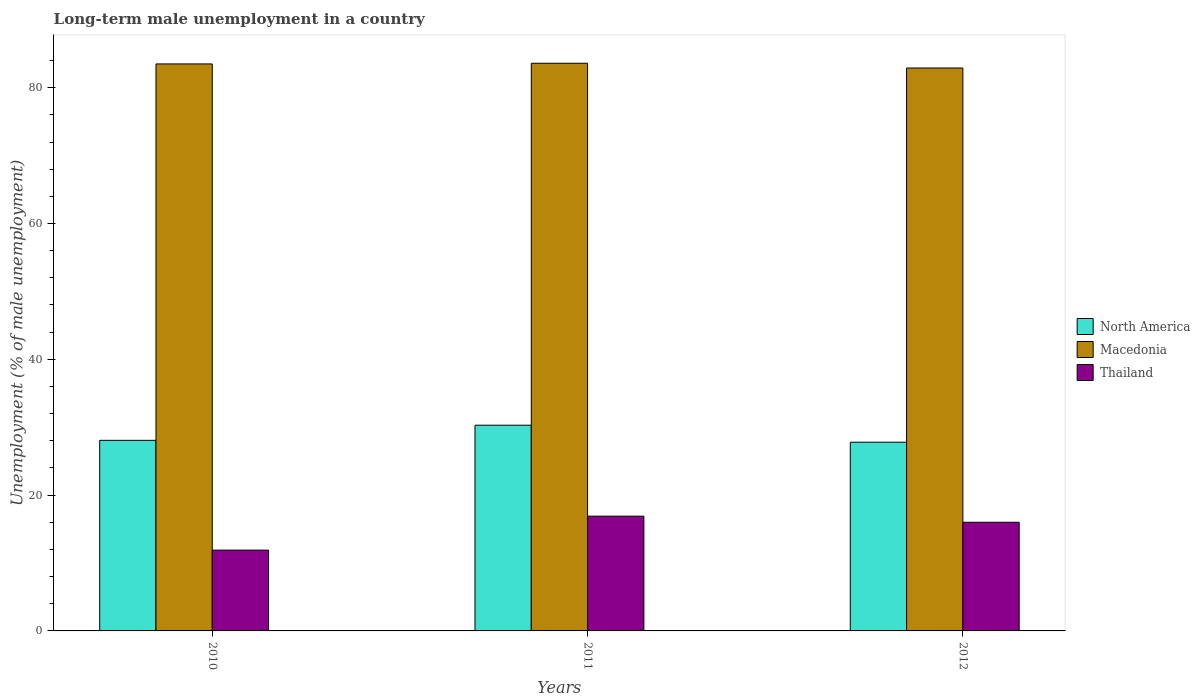How many groups of bars are there?
Offer a very short reply. 3. Are the number of bars per tick equal to the number of legend labels?
Provide a short and direct response. Yes. Are the number of bars on each tick of the X-axis equal?
Provide a short and direct response. Yes. How many bars are there on the 2nd tick from the left?
Keep it short and to the point. 3. What is the percentage of long-term unemployed male population in Macedonia in 2010?
Provide a short and direct response. 83.5. Across all years, what is the maximum percentage of long-term unemployed male population in Macedonia?
Provide a short and direct response. 83.6. Across all years, what is the minimum percentage of long-term unemployed male population in North America?
Keep it short and to the point. 27.79. What is the total percentage of long-term unemployed male population in Macedonia in the graph?
Provide a succinct answer. 250. What is the difference between the percentage of long-term unemployed male population in Macedonia in 2010 and that in 2012?
Your response must be concise. 0.6. What is the difference between the percentage of long-term unemployed male population in North America in 2010 and the percentage of long-term unemployed male population in Macedonia in 2012?
Provide a short and direct response. -54.83. What is the average percentage of long-term unemployed male population in North America per year?
Offer a very short reply. 28.72. In the year 2012, what is the difference between the percentage of long-term unemployed male population in Thailand and percentage of long-term unemployed male population in Macedonia?
Provide a short and direct response. -66.9. In how many years, is the percentage of long-term unemployed male population in Thailand greater than 4 %?
Your answer should be compact. 3. What is the ratio of the percentage of long-term unemployed male population in Thailand in 2010 to that in 2012?
Your answer should be compact. 0.74. What is the difference between the highest and the second highest percentage of long-term unemployed male population in Macedonia?
Offer a terse response. 0.1. What is the difference between the highest and the lowest percentage of long-term unemployed male population in North America?
Give a very brief answer. 2.51. In how many years, is the percentage of long-term unemployed male population in North America greater than the average percentage of long-term unemployed male population in North America taken over all years?
Offer a terse response. 1. Is the sum of the percentage of long-term unemployed male population in North America in 2010 and 2011 greater than the maximum percentage of long-term unemployed male population in Thailand across all years?
Offer a terse response. Yes. What does the 3rd bar from the left in 2012 represents?
Make the answer very short. Thailand. What does the 3rd bar from the right in 2011 represents?
Your answer should be compact. North America. Is it the case that in every year, the sum of the percentage of long-term unemployed male population in North America and percentage of long-term unemployed male population in Thailand is greater than the percentage of long-term unemployed male population in Macedonia?
Give a very brief answer. No. How many bars are there?
Give a very brief answer. 9. What is the difference between two consecutive major ticks on the Y-axis?
Provide a succinct answer. 20. Does the graph contain grids?
Offer a terse response. No. Where does the legend appear in the graph?
Your response must be concise. Center right. How many legend labels are there?
Offer a terse response. 3. What is the title of the graph?
Ensure brevity in your answer.  Long-term male unemployment in a country. What is the label or title of the Y-axis?
Ensure brevity in your answer.  Unemployment (% of male unemployment). What is the Unemployment (% of male unemployment) of North America in 2010?
Provide a short and direct response. 28.07. What is the Unemployment (% of male unemployment) of Macedonia in 2010?
Give a very brief answer. 83.5. What is the Unemployment (% of male unemployment) of Thailand in 2010?
Offer a very short reply. 11.9. What is the Unemployment (% of male unemployment) of North America in 2011?
Offer a terse response. 30.3. What is the Unemployment (% of male unemployment) of Macedonia in 2011?
Give a very brief answer. 83.6. What is the Unemployment (% of male unemployment) in Thailand in 2011?
Make the answer very short. 16.9. What is the Unemployment (% of male unemployment) in North America in 2012?
Keep it short and to the point. 27.79. What is the Unemployment (% of male unemployment) of Macedonia in 2012?
Offer a terse response. 82.9. What is the Unemployment (% of male unemployment) in Thailand in 2012?
Your response must be concise. 16. Across all years, what is the maximum Unemployment (% of male unemployment) in North America?
Offer a terse response. 30.3. Across all years, what is the maximum Unemployment (% of male unemployment) of Macedonia?
Give a very brief answer. 83.6. Across all years, what is the maximum Unemployment (% of male unemployment) in Thailand?
Provide a succinct answer. 16.9. Across all years, what is the minimum Unemployment (% of male unemployment) of North America?
Your answer should be very brief. 27.79. Across all years, what is the minimum Unemployment (% of male unemployment) of Macedonia?
Make the answer very short. 82.9. Across all years, what is the minimum Unemployment (% of male unemployment) in Thailand?
Ensure brevity in your answer.  11.9. What is the total Unemployment (% of male unemployment) of North America in the graph?
Keep it short and to the point. 86.16. What is the total Unemployment (% of male unemployment) in Macedonia in the graph?
Make the answer very short. 250. What is the total Unemployment (% of male unemployment) of Thailand in the graph?
Make the answer very short. 44.8. What is the difference between the Unemployment (% of male unemployment) of North America in 2010 and that in 2011?
Your answer should be very brief. -2.23. What is the difference between the Unemployment (% of male unemployment) in Macedonia in 2010 and that in 2011?
Provide a short and direct response. -0.1. What is the difference between the Unemployment (% of male unemployment) of North America in 2010 and that in 2012?
Offer a very short reply. 0.28. What is the difference between the Unemployment (% of male unemployment) in Macedonia in 2010 and that in 2012?
Your answer should be very brief. 0.6. What is the difference between the Unemployment (% of male unemployment) of North America in 2011 and that in 2012?
Your answer should be very brief. 2.51. What is the difference between the Unemployment (% of male unemployment) of Macedonia in 2011 and that in 2012?
Keep it short and to the point. 0.7. What is the difference between the Unemployment (% of male unemployment) of North America in 2010 and the Unemployment (% of male unemployment) of Macedonia in 2011?
Ensure brevity in your answer.  -55.53. What is the difference between the Unemployment (% of male unemployment) in North America in 2010 and the Unemployment (% of male unemployment) in Thailand in 2011?
Your response must be concise. 11.17. What is the difference between the Unemployment (% of male unemployment) in Macedonia in 2010 and the Unemployment (% of male unemployment) in Thailand in 2011?
Offer a terse response. 66.6. What is the difference between the Unemployment (% of male unemployment) of North America in 2010 and the Unemployment (% of male unemployment) of Macedonia in 2012?
Make the answer very short. -54.83. What is the difference between the Unemployment (% of male unemployment) of North America in 2010 and the Unemployment (% of male unemployment) of Thailand in 2012?
Your answer should be very brief. 12.07. What is the difference between the Unemployment (% of male unemployment) of Macedonia in 2010 and the Unemployment (% of male unemployment) of Thailand in 2012?
Make the answer very short. 67.5. What is the difference between the Unemployment (% of male unemployment) in North America in 2011 and the Unemployment (% of male unemployment) in Macedonia in 2012?
Your response must be concise. -52.6. What is the difference between the Unemployment (% of male unemployment) of North America in 2011 and the Unemployment (% of male unemployment) of Thailand in 2012?
Your answer should be very brief. 14.3. What is the difference between the Unemployment (% of male unemployment) of Macedonia in 2011 and the Unemployment (% of male unemployment) of Thailand in 2012?
Offer a very short reply. 67.6. What is the average Unemployment (% of male unemployment) in North America per year?
Make the answer very short. 28.72. What is the average Unemployment (% of male unemployment) of Macedonia per year?
Provide a short and direct response. 83.33. What is the average Unemployment (% of male unemployment) of Thailand per year?
Ensure brevity in your answer.  14.93. In the year 2010, what is the difference between the Unemployment (% of male unemployment) in North America and Unemployment (% of male unemployment) in Macedonia?
Ensure brevity in your answer.  -55.43. In the year 2010, what is the difference between the Unemployment (% of male unemployment) in North America and Unemployment (% of male unemployment) in Thailand?
Keep it short and to the point. 16.17. In the year 2010, what is the difference between the Unemployment (% of male unemployment) in Macedonia and Unemployment (% of male unemployment) in Thailand?
Offer a very short reply. 71.6. In the year 2011, what is the difference between the Unemployment (% of male unemployment) of North America and Unemployment (% of male unemployment) of Macedonia?
Ensure brevity in your answer.  -53.3. In the year 2011, what is the difference between the Unemployment (% of male unemployment) of North America and Unemployment (% of male unemployment) of Thailand?
Provide a succinct answer. 13.4. In the year 2011, what is the difference between the Unemployment (% of male unemployment) of Macedonia and Unemployment (% of male unemployment) of Thailand?
Keep it short and to the point. 66.7. In the year 2012, what is the difference between the Unemployment (% of male unemployment) in North America and Unemployment (% of male unemployment) in Macedonia?
Your answer should be very brief. -55.11. In the year 2012, what is the difference between the Unemployment (% of male unemployment) of North America and Unemployment (% of male unemployment) of Thailand?
Your response must be concise. 11.79. In the year 2012, what is the difference between the Unemployment (% of male unemployment) in Macedonia and Unemployment (% of male unemployment) in Thailand?
Give a very brief answer. 66.9. What is the ratio of the Unemployment (% of male unemployment) in North America in 2010 to that in 2011?
Provide a succinct answer. 0.93. What is the ratio of the Unemployment (% of male unemployment) in Macedonia in 2010 to that in 2011?
Offer a terse response. 1. What is the ratio of the Unemployment (% of male unemployment) in Thailand in 2010 to that in 2011?
Give a very brief answer. 0.7. What is the ratio of the Unemployment (% of male unemployment) in Macedonia in 2010 to that in 2012?
Your response must be concise. 1.01. What is the ratio of the Unemployment (% of male unemployment) of Thailand in 2010 to that in 2012?
Provide a succinct answer. 0.74. What is the ratio of the Unemployment (% of male unemployment) of North America in 2011 to that in 2012?
Give a very brief answer. 1.09. What is the ratio of the Unemployment (% of male unemployment) of Macedonia in 2011 to that in 2012?
Provide a succinct answer. 1.01. What is the ratio of the Unemployment (% of male unemployment) in Thailand in 2011 to that in 2012?
Your answer should be compact. 1.06. What is the difference between the highest and the second highest Unemployment (% of male unemployment) in North America?
Offer a terse response. 2.23. What is the difference between the highest and the second highest Unemployment (% of male unemployment) of Macedonia?
Offer a very short reply. 0.1. What is the difference between the highest and the lowest Unemployment (% of male unemployment) in North America?
Your response must be concise. 2.51. What is the difference between the highest and the lowest Unemployment (% of male unemployment) of Macedonia?
Your answer should be compact. 0.7. 